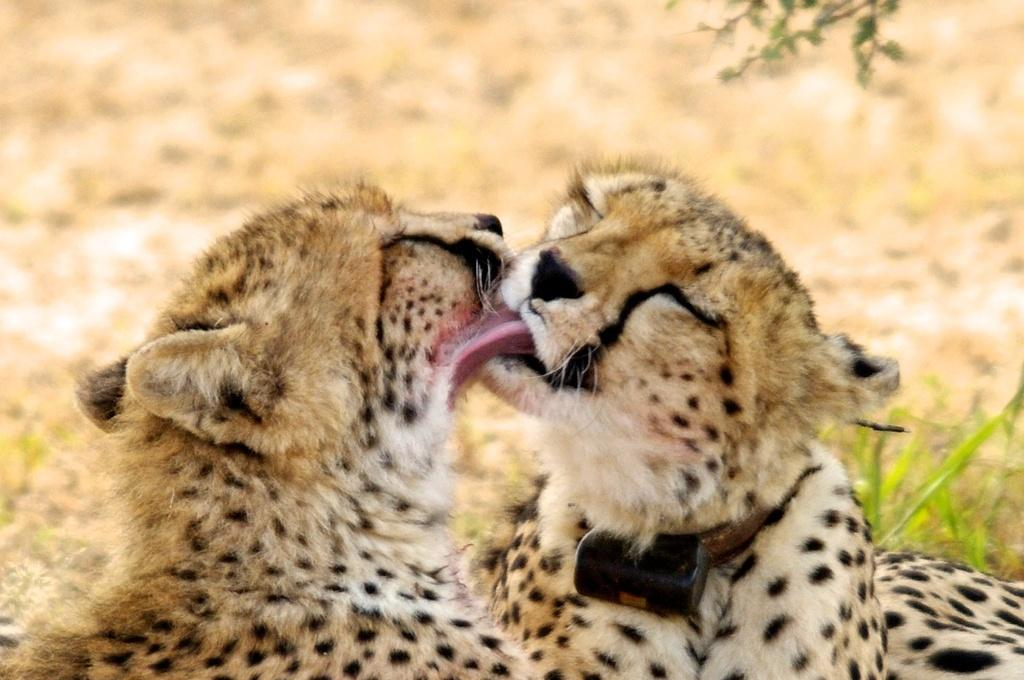How many animals are present in the image? There are two animals in the image. What colors can be seen on the animals? The animals are in cream, white, and black colors. What can be seen in the background of the image? There are plants in the background of the image. What color are the plants? The plants are green in color. How many trucks are transporting men in the image? There are no trucks or men present in the image; it features two animals and plants in the background. 